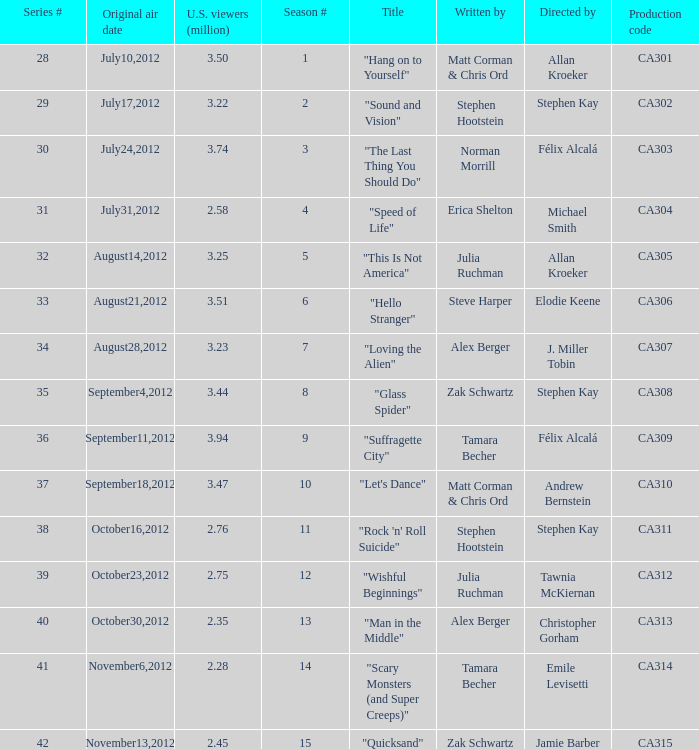Who directed the episode with production code ca311? Stephen Kay. 